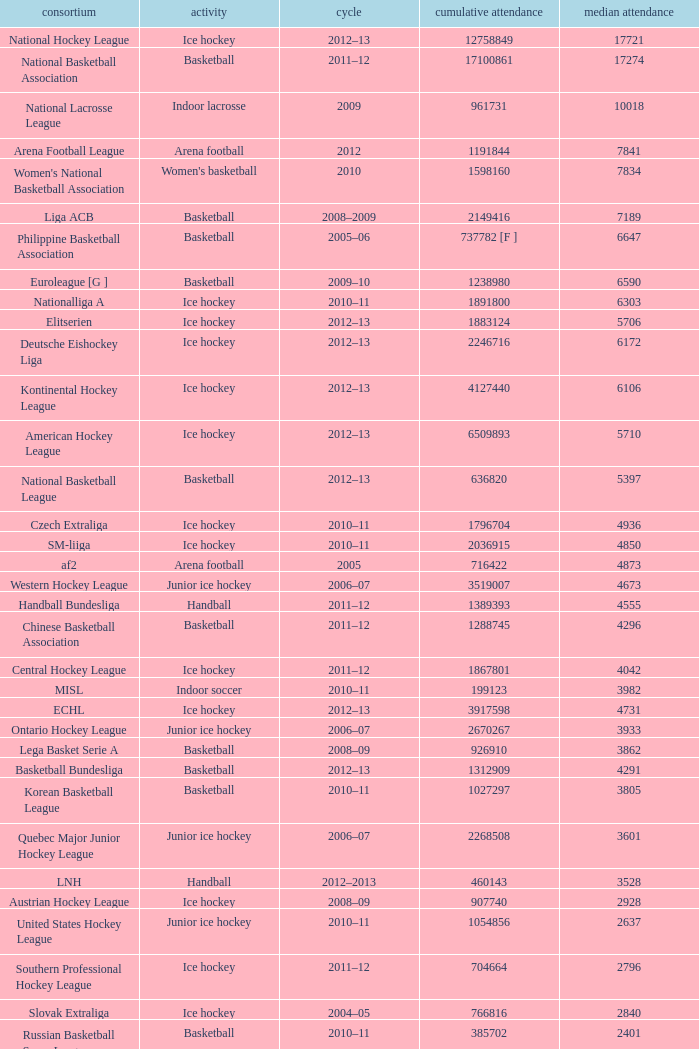What's the total attendance in rink hockey when the average attendance was smaller than 4850? 115000.0. 